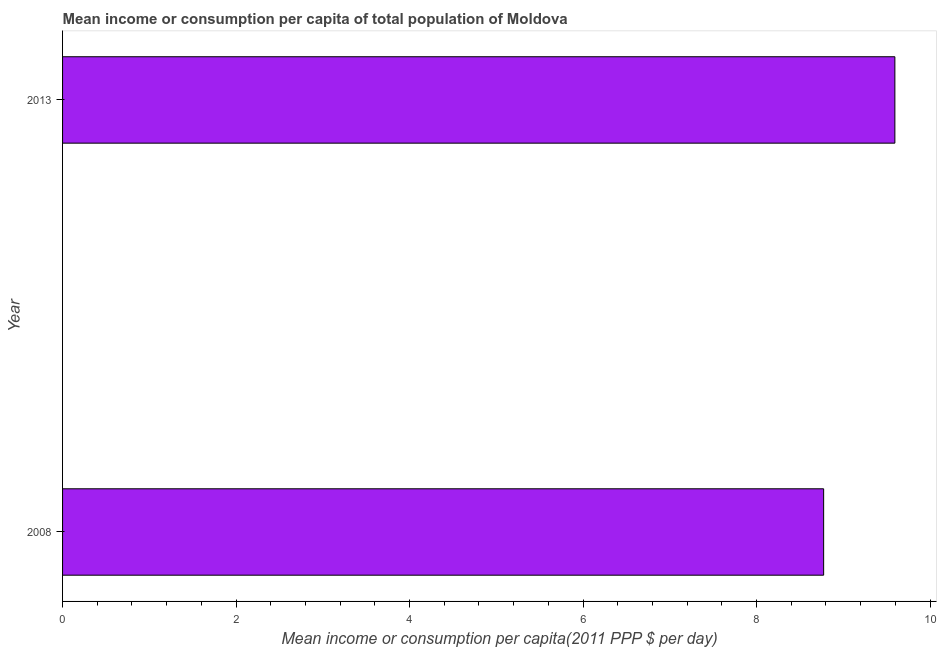Does the graph contain any zero values?
Keep it short and to the point. No. Does the graph contain grids?
Give a very brief answer. No. What is the title of the graph?
Offer a very short reply. Mean income or consumption per capita of total population of Moldova. What is the label or title of the X-axis?
Make the answer very short. Mean income or consumption per capita(2011 PPP $ per day). What is the label or title of the Y-axis?
Your answer should be compact. Year. What is the mean income or consumption in 2008?
Give a very brief answer. 8.77. Across all years, what is the maximum mean income or consumption?
Your answer should be compact. 9.59. Across all years, what is the minimum mean income or consumption?
Make the answer very short. 8.77. In which year was the mean income or consumption maximum?
Provide a succinct answer. 2013. In which year was the mean income or consumption minimum?
Keep it short and to the point. 2008. What is the sum of the mean income or consumption?
Your answer should be very brief. 18.37. What is the difference between the mean income or consumption in 2008 and 2013?
Give a very brief answer. -0.82. What is the average mean income or consumption per year?
Your answer should be very brief. 9.18. What is the median mean income or consumption?
Your answer should be compact. 9.18. In how many years, is the mean income or consumption greater than 3.2 $?
Your answer should be very brief. 2. What is the ratio of the mean income or consumption in 2008 to that in 2013?
Your answer should be compact. 0.91. In how many years, is the mean income or consumption greater than the average mean income or consumption taken over all years?
Give a very brief answer. 1. How many bars are there?
Your answer should be compact. 2. Are the values on the major ticks of X-axis written in scientific E-notation?
Provide a short and direct response. No. What is the Mean income or consumption per capita(2011 PPP $ per day) of 2008?
Provide a succinct answer. 8.77. What is the Mean income or consumption per capita(2011 PPP $ per day) of 2013?
Offer a terse response. 9.59. What is the difference between the Mean income or consumption per capita(2011 PPP $ per day) in 2008 and 2013?
Your answer should be compact. -0.82. What is the ratio of the Mean income or consumption per capita(2011 PPP $ per day) in 2008 to that in 2013?
Your response must be concise. 0.91. 